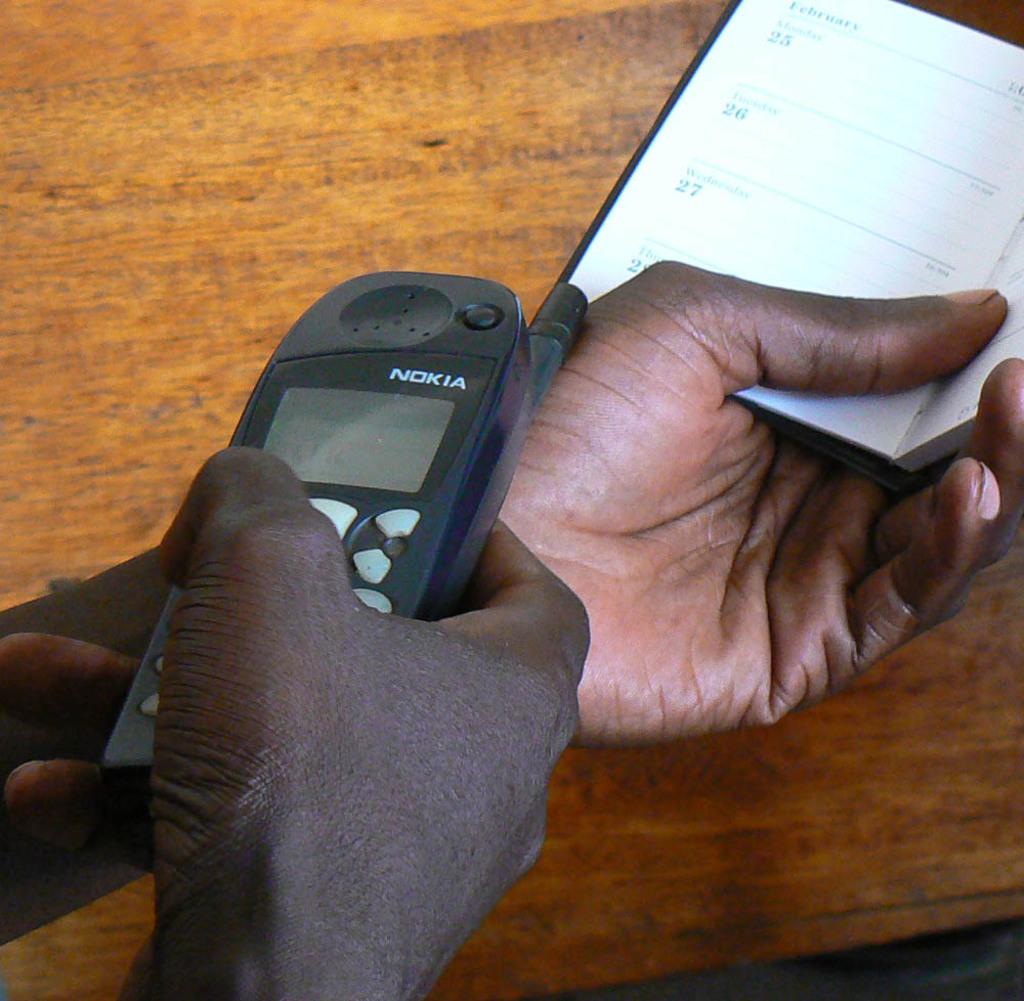What brand phone is this?
Provide a succinct answer. Nokia. What is the date on wednesday in the planner?
Provide a succinct answer. 27. 